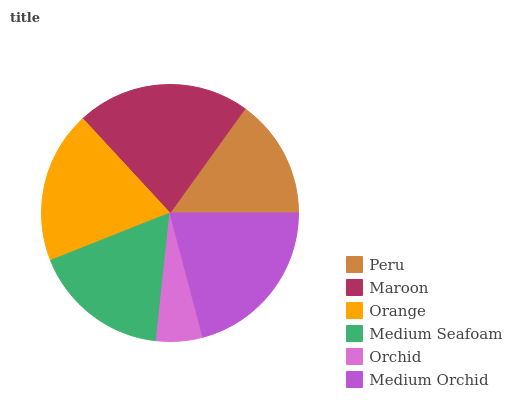Is Orchid the minimum?
Answer yes or no. Yes. Is Maroon the maximum?
Answer yes or no. Yes. Is Orange the minimum?
Answer yes or no. No. Is Orange the maximum?
Answer yes or no. No. Is Maroon greater than Orange?
Answer yes or no. Yes. Is Orange less than Maroon?
Answer yes or no. Yes. Is Orange greater than Maroon?
Answer yes or no. No. Is Maroon less than Orange?
Answer yes or no. No. Is Orange the high median?
Answer yes or no. Yes. Is Medium Seafoam the low median?
Answer yes or no. Yes. Is Orchid the high median?
Answer yes or no. No. Is Peru the low median?
Answer yes or no. No. 